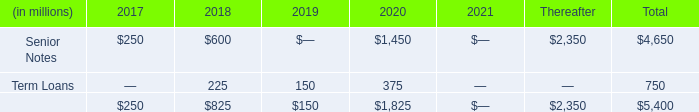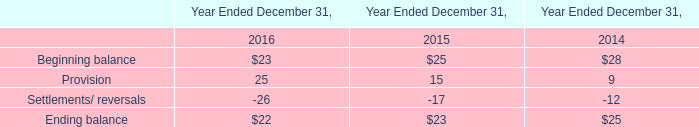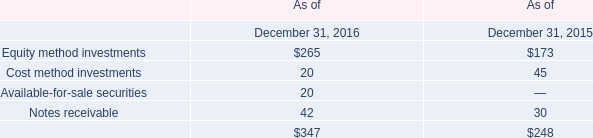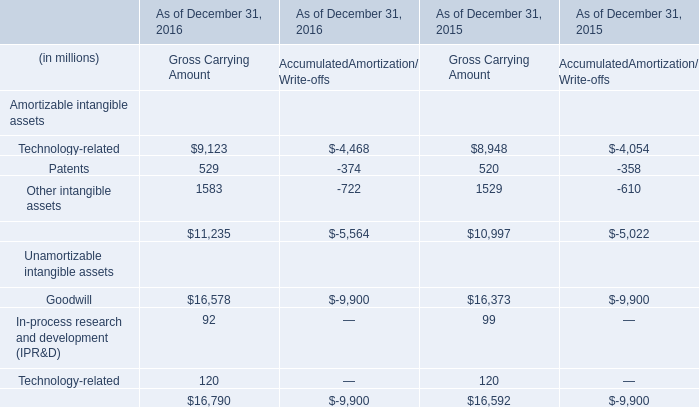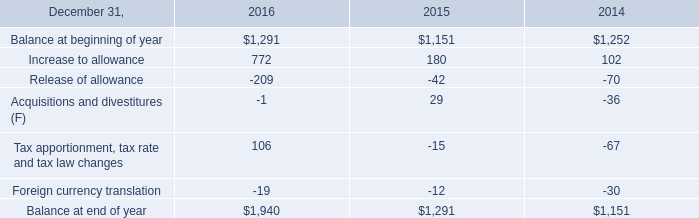What is the difference between 2016 and 2015 's highest section? (in dollars) 
Computations: (347 - 248)
Answer: 99.0. 